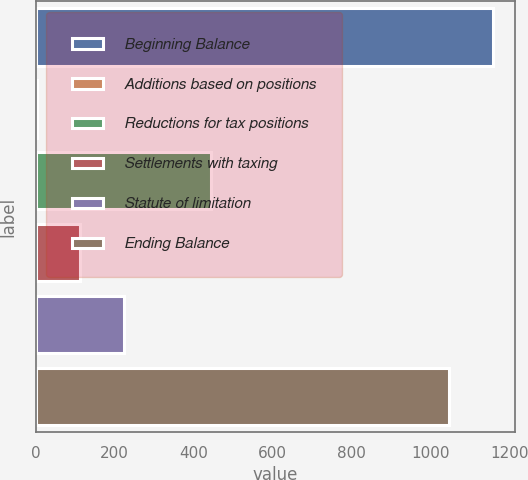Convert chart to OTSL. <chart><loc_0><loc_0><loc_500><loc_500><bar_chart><fcel>Beginning Balance<fcel>Additions based on positions<fcel>Reductions for tax positions<fcel>Settlements with taxing<fcel>Statute of limitation<fcel>Ending Balance<nl><fcel>1156.9<fcel>3<fcel>442.6<fcel>112.9<fcel>222.8<fcel>1047<nl></chart> 